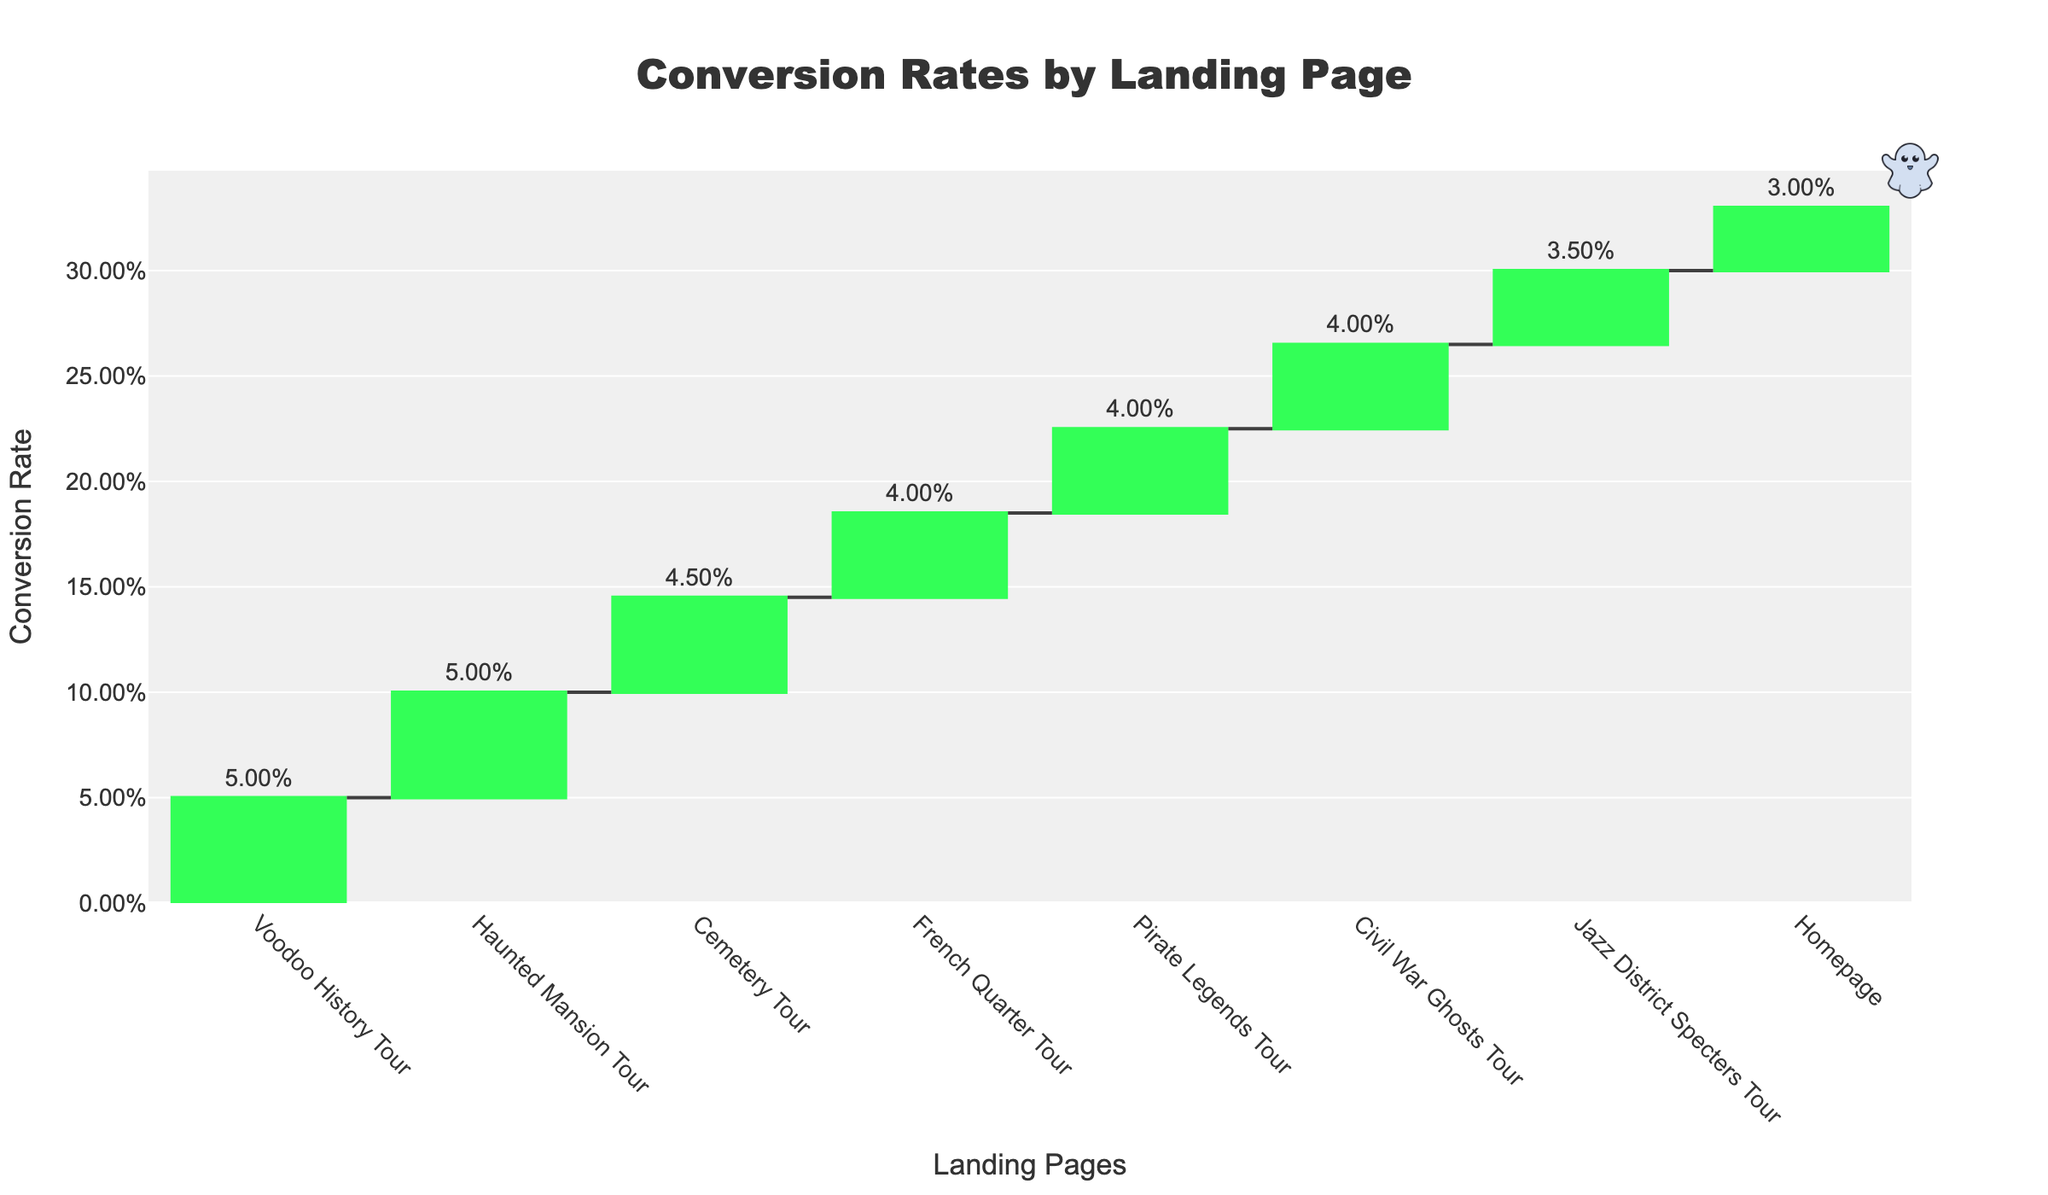What's the highest conversion rate? The highest conversion rate can be found by looking at the bar that reaches the highest relative position on the y-axis, which measures conversion rates. The Voodoo History Tour and Haunted Mansion Tour have the highest conversion rates, both at 5.00%.
Answer: Voodoo History Tour & Haunted Mansion Tour Which landing page has the lowest conversion rate? The lowest conversion rate can be found by identifying the bar with the lowest relative position on the y-axis. The Homepage has the lowest conversion rate at 3.00%.
Answer: Homepage How many landing pages have a conversion rate of 4.00%? To find how many landing pages have a conversion rate of 4.00%, we need to count the bars labeled with a 4.00% conversion rate. The French Quarter Tour, Pirate Legends Tour, and Civil War Ghosts Tour all have a conversion rate of 4.00%, making it three landing pages in total.
Answer: 3 What's the sum of the conversion rates of the French Quarter Tour and the Cemetery Tour? To find the sum of the conversion rates, add the conversion rates of the French Quarter Tour (4.00%) and the Cemetery Tour (4.50%). The sum is 4.00% + 4.50% = 8.50%.
Answer: 8.50% Which landing page has a higher conversion rate, Civil War Ghosts Tour, or Jazz District Specters Tour? To compare the conversion rates, look at the heights of the bars for each tour. The Civil War Ghosts Tour has a conversion rate of 4.00%, whereas the Jazz District Specters Tour has a conversion rate of 3.50%. Therefore, the Civil War Ghosts Tour has a higher conversion rate.
Answer: Civil War Ghosts Tour What is the overall average conversion rate for all listed landing pages? To find the overall average conversion rate, sum the conversion rates of all landing pages and divide by the number of landing pages. The total conversion rates are 5.00% + 5.00% + 4.50% + 4.00% + 4.00% + 4.00% + 3.50% + 3.00% = 33.00%. Dividing by 8 landing pages gives 33.00% / 8 = 4.125%.
Answer: 4.125% Which group of landing pages (those with a conversion rate above 4.00% and those with a conversion rate below or equal to 4.00%) has more pages? Count the pages with conversion rates above 4.00% (Voodoo History Tour, Haunted Mansion Tour, Cemetery Tour) which is 3, and those with rates below or equal to 4.00% (French Quarter Tour, Pirate Legends Tour, Civil War Ghosts Tour, Jazz District Specters Tour, Homepage) which is 5. The group with rates below or equal to 4.00% has more pages.
Answer: Below or equal to 4.00% What's the difference in conversion rates between the Cemetery Tour and the Pirate Legends Tour? Subtract the conversion rate of the Pirate Legends Tour (4.00%) from the conversion rate of the Cemetery Tour (4.50%), resulting in a difference of 0.50%.
Answer: 0.50% How many pages have a conversion rate equal to or above 4.50%? Count the bars with conversion rates of 4.50% or higher. The Voodoo History Tour, Haunted Mansion Tour, and Cemetery Tour all have conversion rates equal to or above 4.50%, making it three pages in total.
Answer: 3 